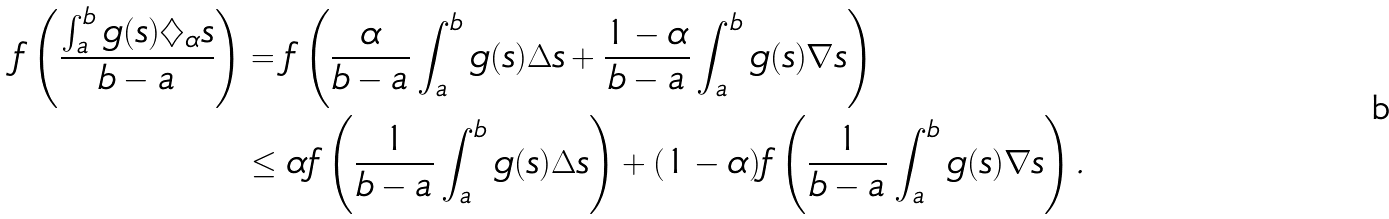Convert formula to latex. <formula><loc_0><loc_0><loc_500><loc_500>f \left ( \frac { \int _ { a } ^ { b } g ( s ) \diamondsuit _ { \alpha } s } { b - a } \right ) & = f \left ( \frac { \alpha } { b - a } \int _ { a } ^ { b } g ( s ) \Delta s + \frac { 1 - \alpha } { b - a } \int _ { a } ^ { b } g ( s ) \nabla s \right ) \\ & \leq \alpha f \left ( \frac { 1 } { b - a } \int _ { a } ^ { b } g ( s ) \Delta s \right ) + ( 1 - \alpha ) f \left ( \frac { 1 } { b - a } \int _ { a } ^ { b } g ( s ) \nabla s \right ) .</formula> 